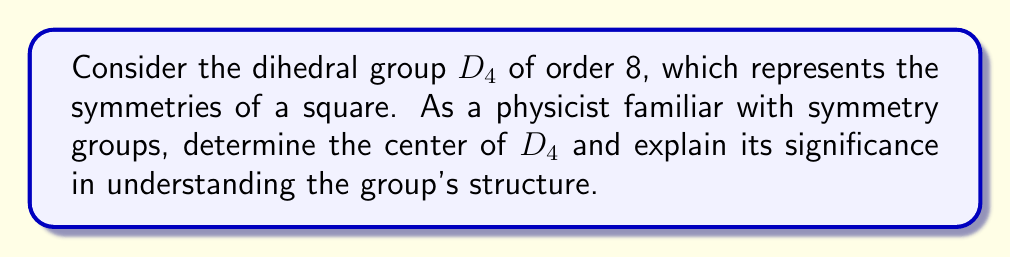Can you solve this math problem? To find the center of $D_4$ and understand its significance, let's follow these steps:

1) Recall that the center of a group $G$ is defined as:
   $$Z(G) = \{z \in G : gz = zg \text{ for all } g \in G\}$$

2) The dihedral group $D_4$ consists of 8 elements:
   - Identity element: $e$
   - Rotations: $r, r^2, r^3$ (rotations by 90°, 180°, 270°)
   - Reflections: $s, sr, sr^2, sr^3$ (reflections across various axes)

3) To find the center, we need to identify elements that commute with all other elements in the group.

4) The identity $e$ always commutes with every element, so $e \in Z(D_4)$.

5) Let's consider $r^2$ (180° rotation):
   - $r^2$ commutes with all rotations trivially
   - For reflections: $sr^2 = r^2s$ (rotating 180° then reflecting is the same as reflecting then rotating 180°)

6) All other elements do not commute with each other. For example:
   $rs \neq sr$ (rotating then reflecting is not the same as reflecting then rotating)

7) Therefore, the center of $D_4$ is:
   $$Z(D_4) = \{e, r^2\}$$

Significance:

a) The center being non-trivial (not just the identity) indicates that $D_4$ is not a simple group.

b) The fact that $|Z(D_4)| = 2$ tells us that $D_4$ has a normal subgroup of order 2.

c) The quotient group $D_4/Z(D_4)$ is isomorphic to the Klein four-group $V_4$, which is abelian. This illustrates how the center relates to the abelian nature of quotient groups.

d) In physics, the center of a symmetry group often corresponds to global symmetries that commute with all other symmetry operations, which can have important implications for conservation laws and selection rules in quantum systems.
Answer: The center of $D_4$ is $Z(D_4) = \{e, r^2\}$, where $e$ is the identity and $r^2$ is the 180° rotation. This non-trivial center indicates that $D_4$ is not simple, has a normal subgroup of order 2, and its quotient by the center is abelian. 